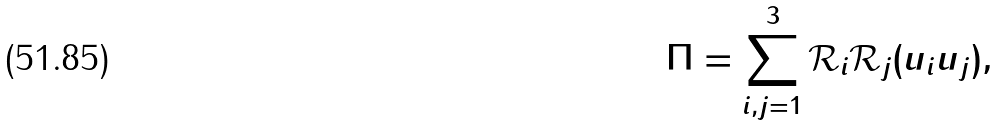<formula> <loc_0><loc_0><loc_500><loc_500>\Pi = \sum _ { i , j = 1 } ^ { 3 } \mathcal { R } _ { i } \mathcal { R } _ { j } ( u _ { i } u _ { j } ) ,</formula> 